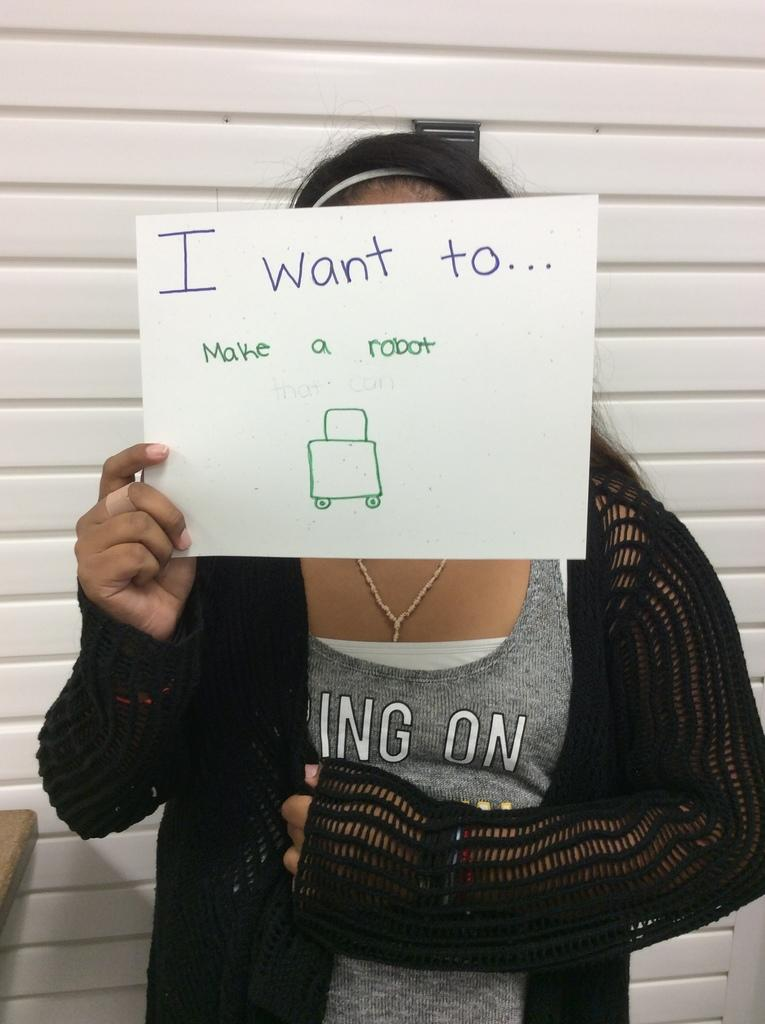What is the person in the image doing? The person is holding a paper. What is visible behind the person? There is a wall behind the person. What object is located beside the person? There is a table beside the person. What type of tail can be seen on the person in the image? There is no tail visible on the person in the image. What rate of speed is the person in the image moving at? The image does not provide information about the person's speed, so it cannot be determined. 